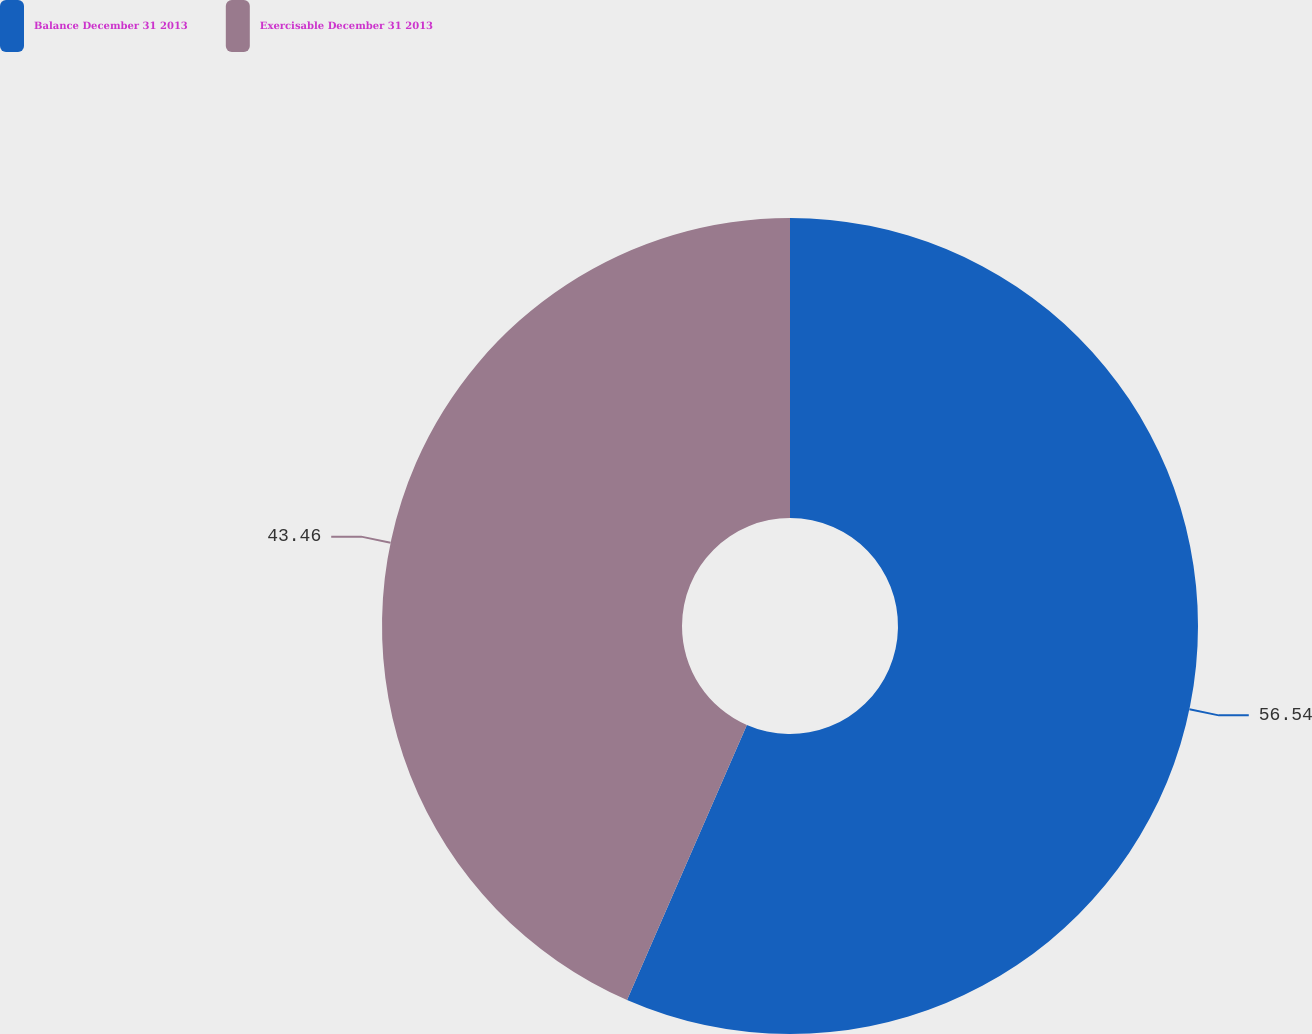<chart> <loc_0><loc_0><loc_500><loc_500><pie_chart><fcel>Balance December 31 2013<fcel>Exercisable December 31 2013<nl><fcel>56.54%<fcel>43.46%<nl></chart> 